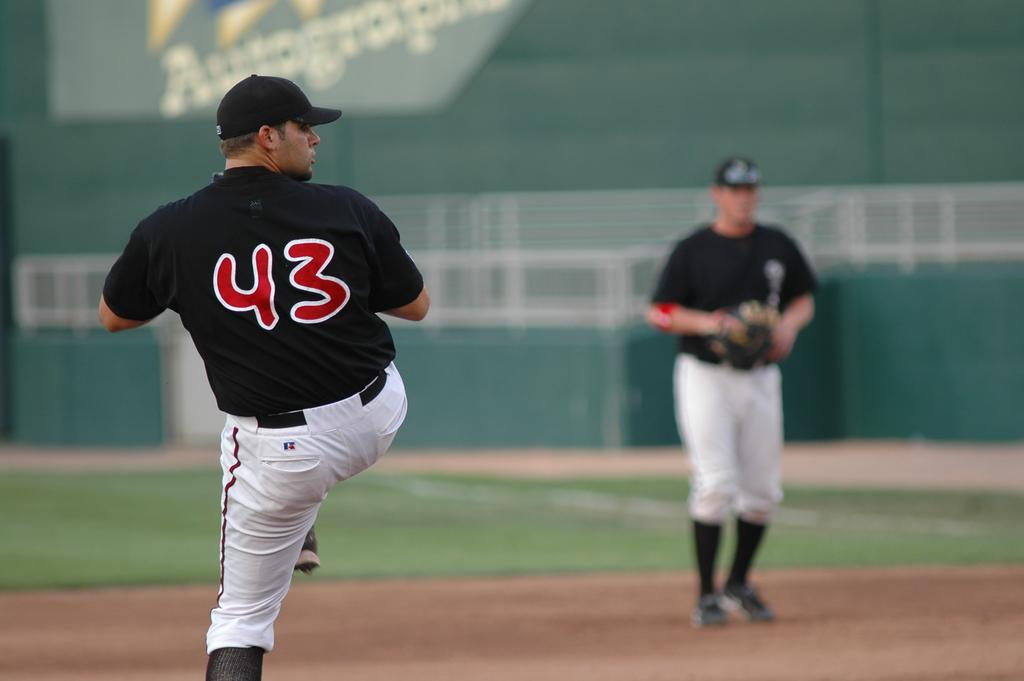<image>
Create a compact narrative representing the image presented. Some sports players, one of whom has 43 on the back of his shirt 